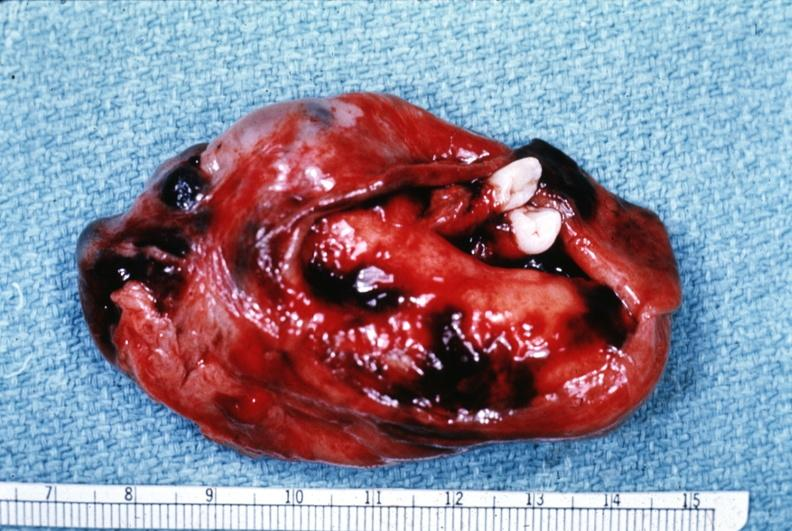s female reproductive present?
Answer the question using a single word or phrase. Yes 